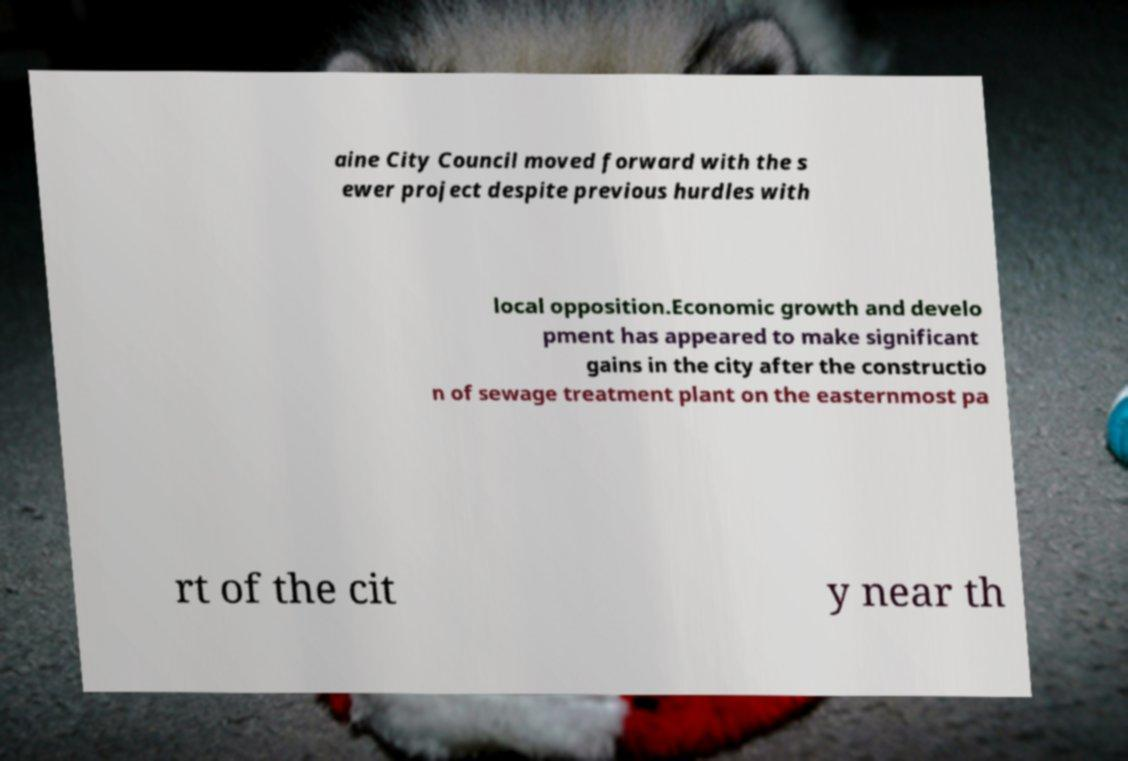Please identify and transcribe the text found in this image. aine City Council moved forward with the s ewer project despite previous hurdles with local opposition.Economic growth and develo pment has appeared to make significant gains in the city after the constructio n of sewage treatment plant on the easternmost pa rt of the cit y near th 